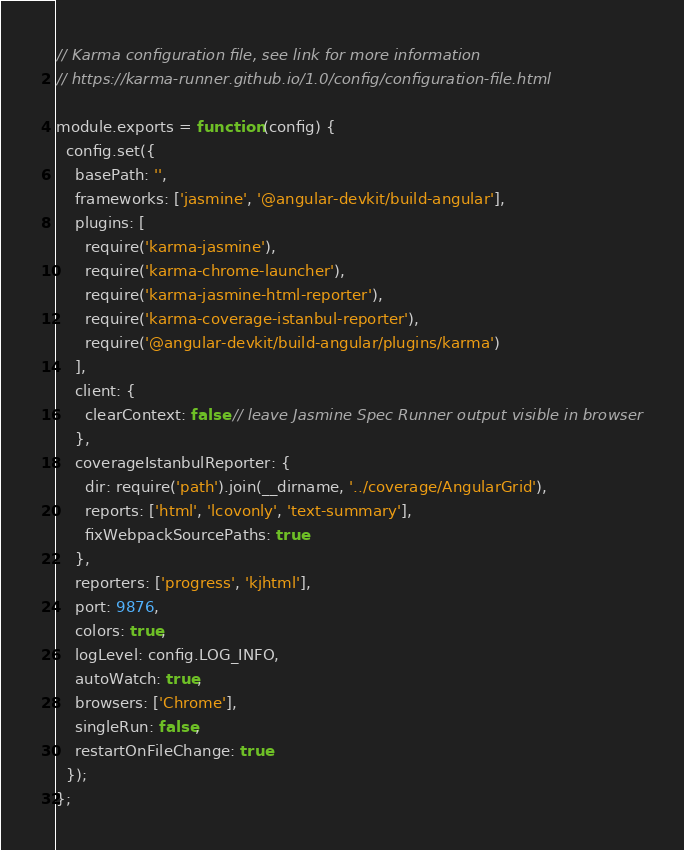Convert code to text. <code><loc_0><loc_0><loc_500><loc_500><_JavaScript_>// Karma configuration file, see link for more information
// https://karma-runner.github.io/1.0/config/configuration-file.html

module.exports = function (config) {
  config.set({
    basePath: '',
    frameworks: ['jasmine', '@angular-devkit/build-angular'],
    plugins: [
      require('karma-jasmine'),
      require('karma-chrome-launcher'),
      require('karma-jasmine-html-reporter'),
      require('karma-coverage-istanbul-reporter'),
      require('@angular-devkit/build-angular/plugins/karma')
    ],
    client: {
      clearContext: false // leave Jasmine Spec Runner output visible in browser
    },
    coverageIstanbulReporter: {
      dir: require('path').join(__dirname, '../coverage/AngularGrid'),
      reports: ['html', 'lcovonly', 'text-summary'],
      fixWebpackSourcePaths: true
    },
    reporters: ['progress', 'kjhtml'],
    port: 9876,
    colors: true,
    logLevel: config.LOG_INFO,
    autoWatch: true,
    browsers: ['Chrome'],
    singleRun: false,
    restartOnFileChange: true
  });
};
</code> 